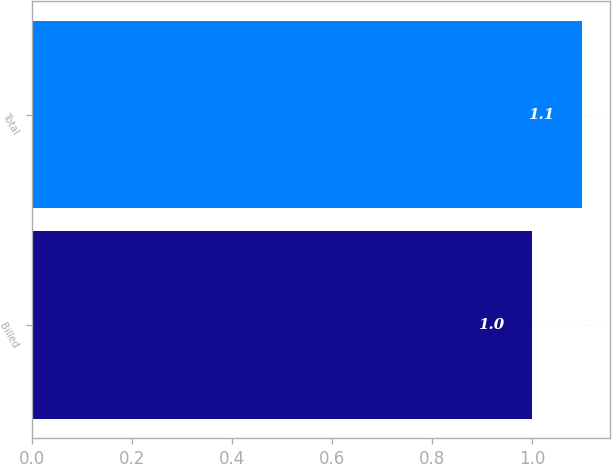<chart> <loc_0><loc_0><loc_500><loc_500><bar_chart><fcel>Billed<fcel>Total<nl><fcel>1<fcel>1.1<nl></chart> 